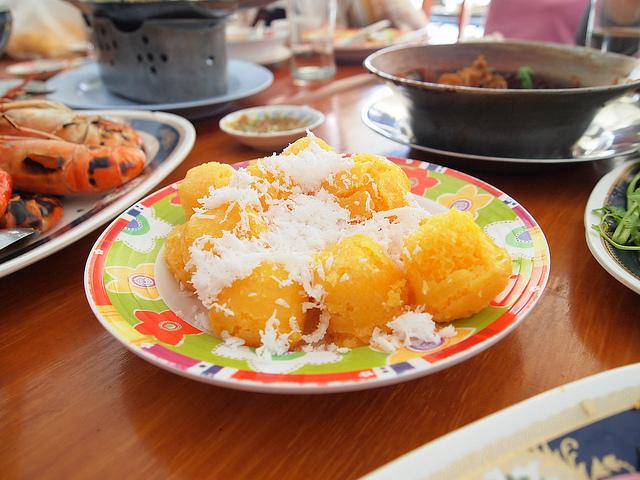What colors are on the edge of the closest plate?
Short answer required. White and tan. What material are the plates made of?
Keep it brief. Ceramic. What is the shape of closest plate?
Answer briefly. Round. Is there meat in this picture?
Concise answer only. Yes. 